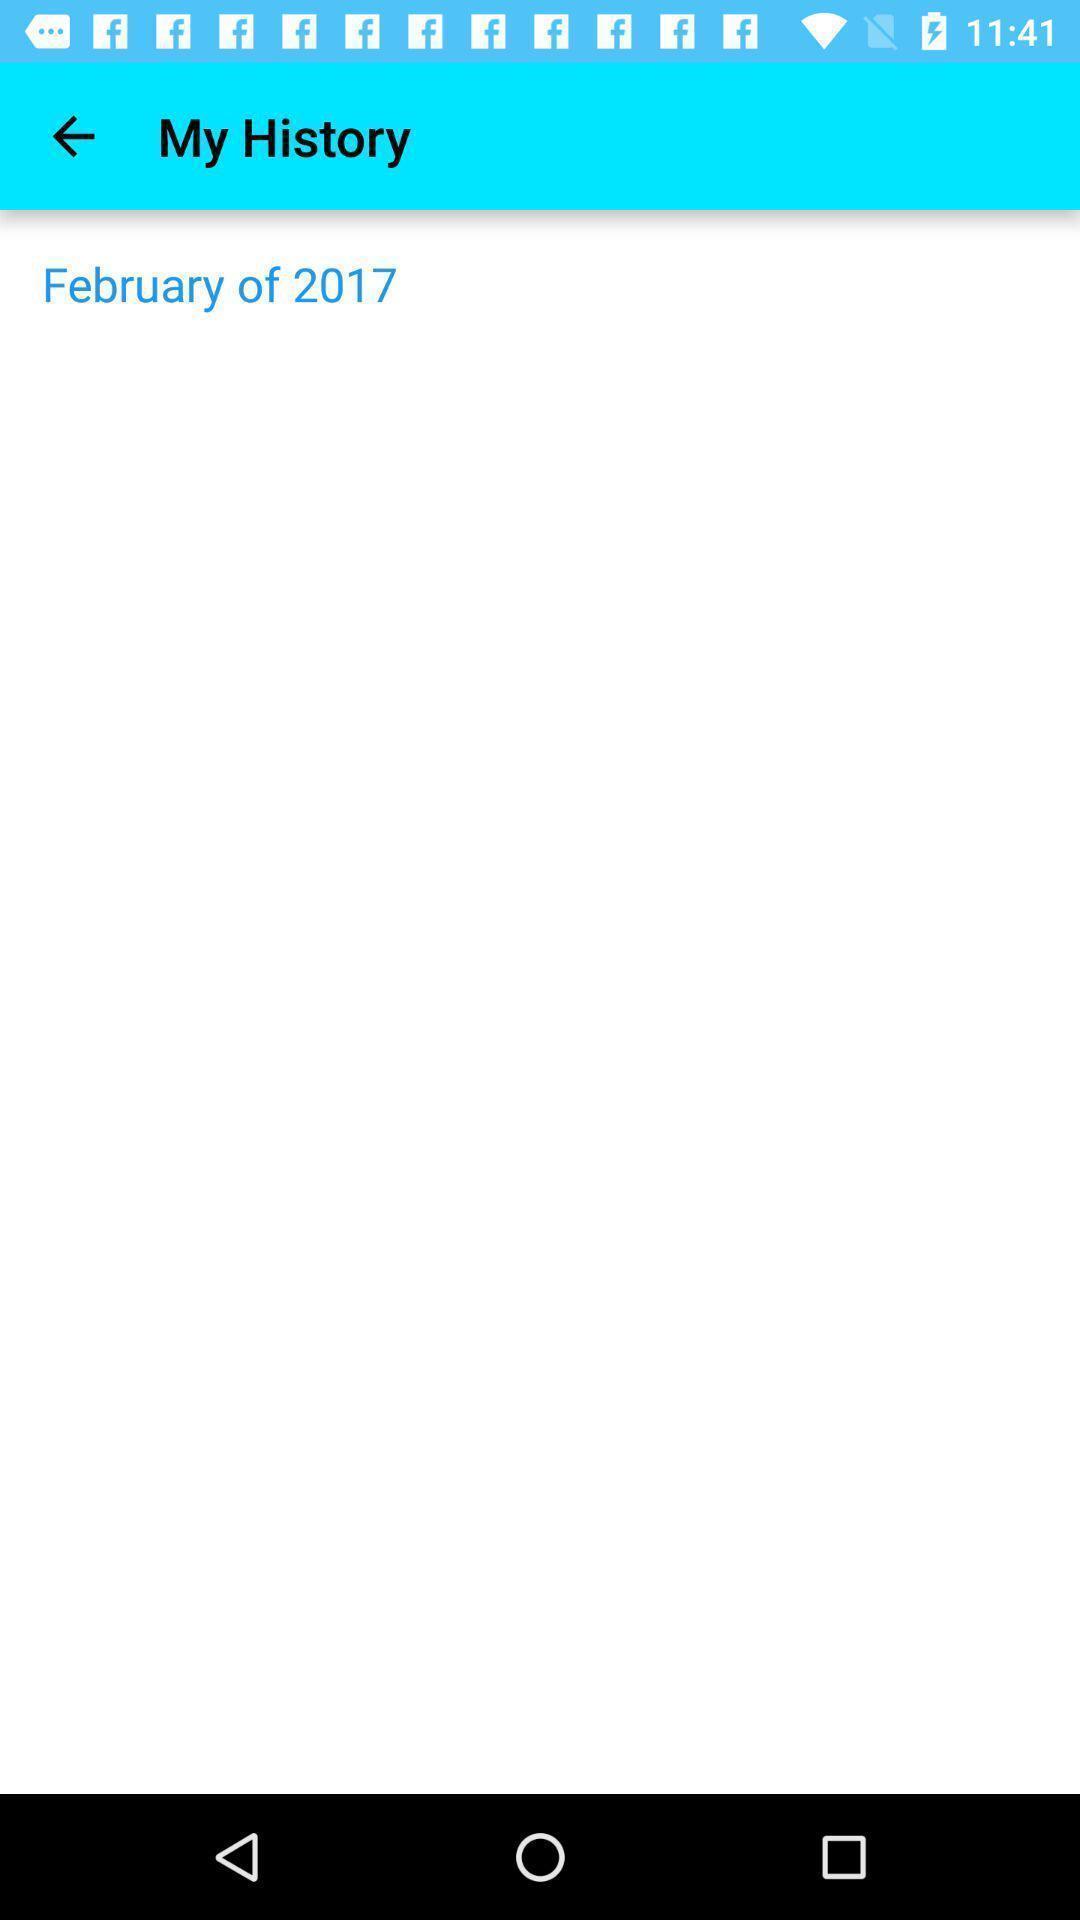What details can you identify in this image? Screen showing blank page in my history tab. 